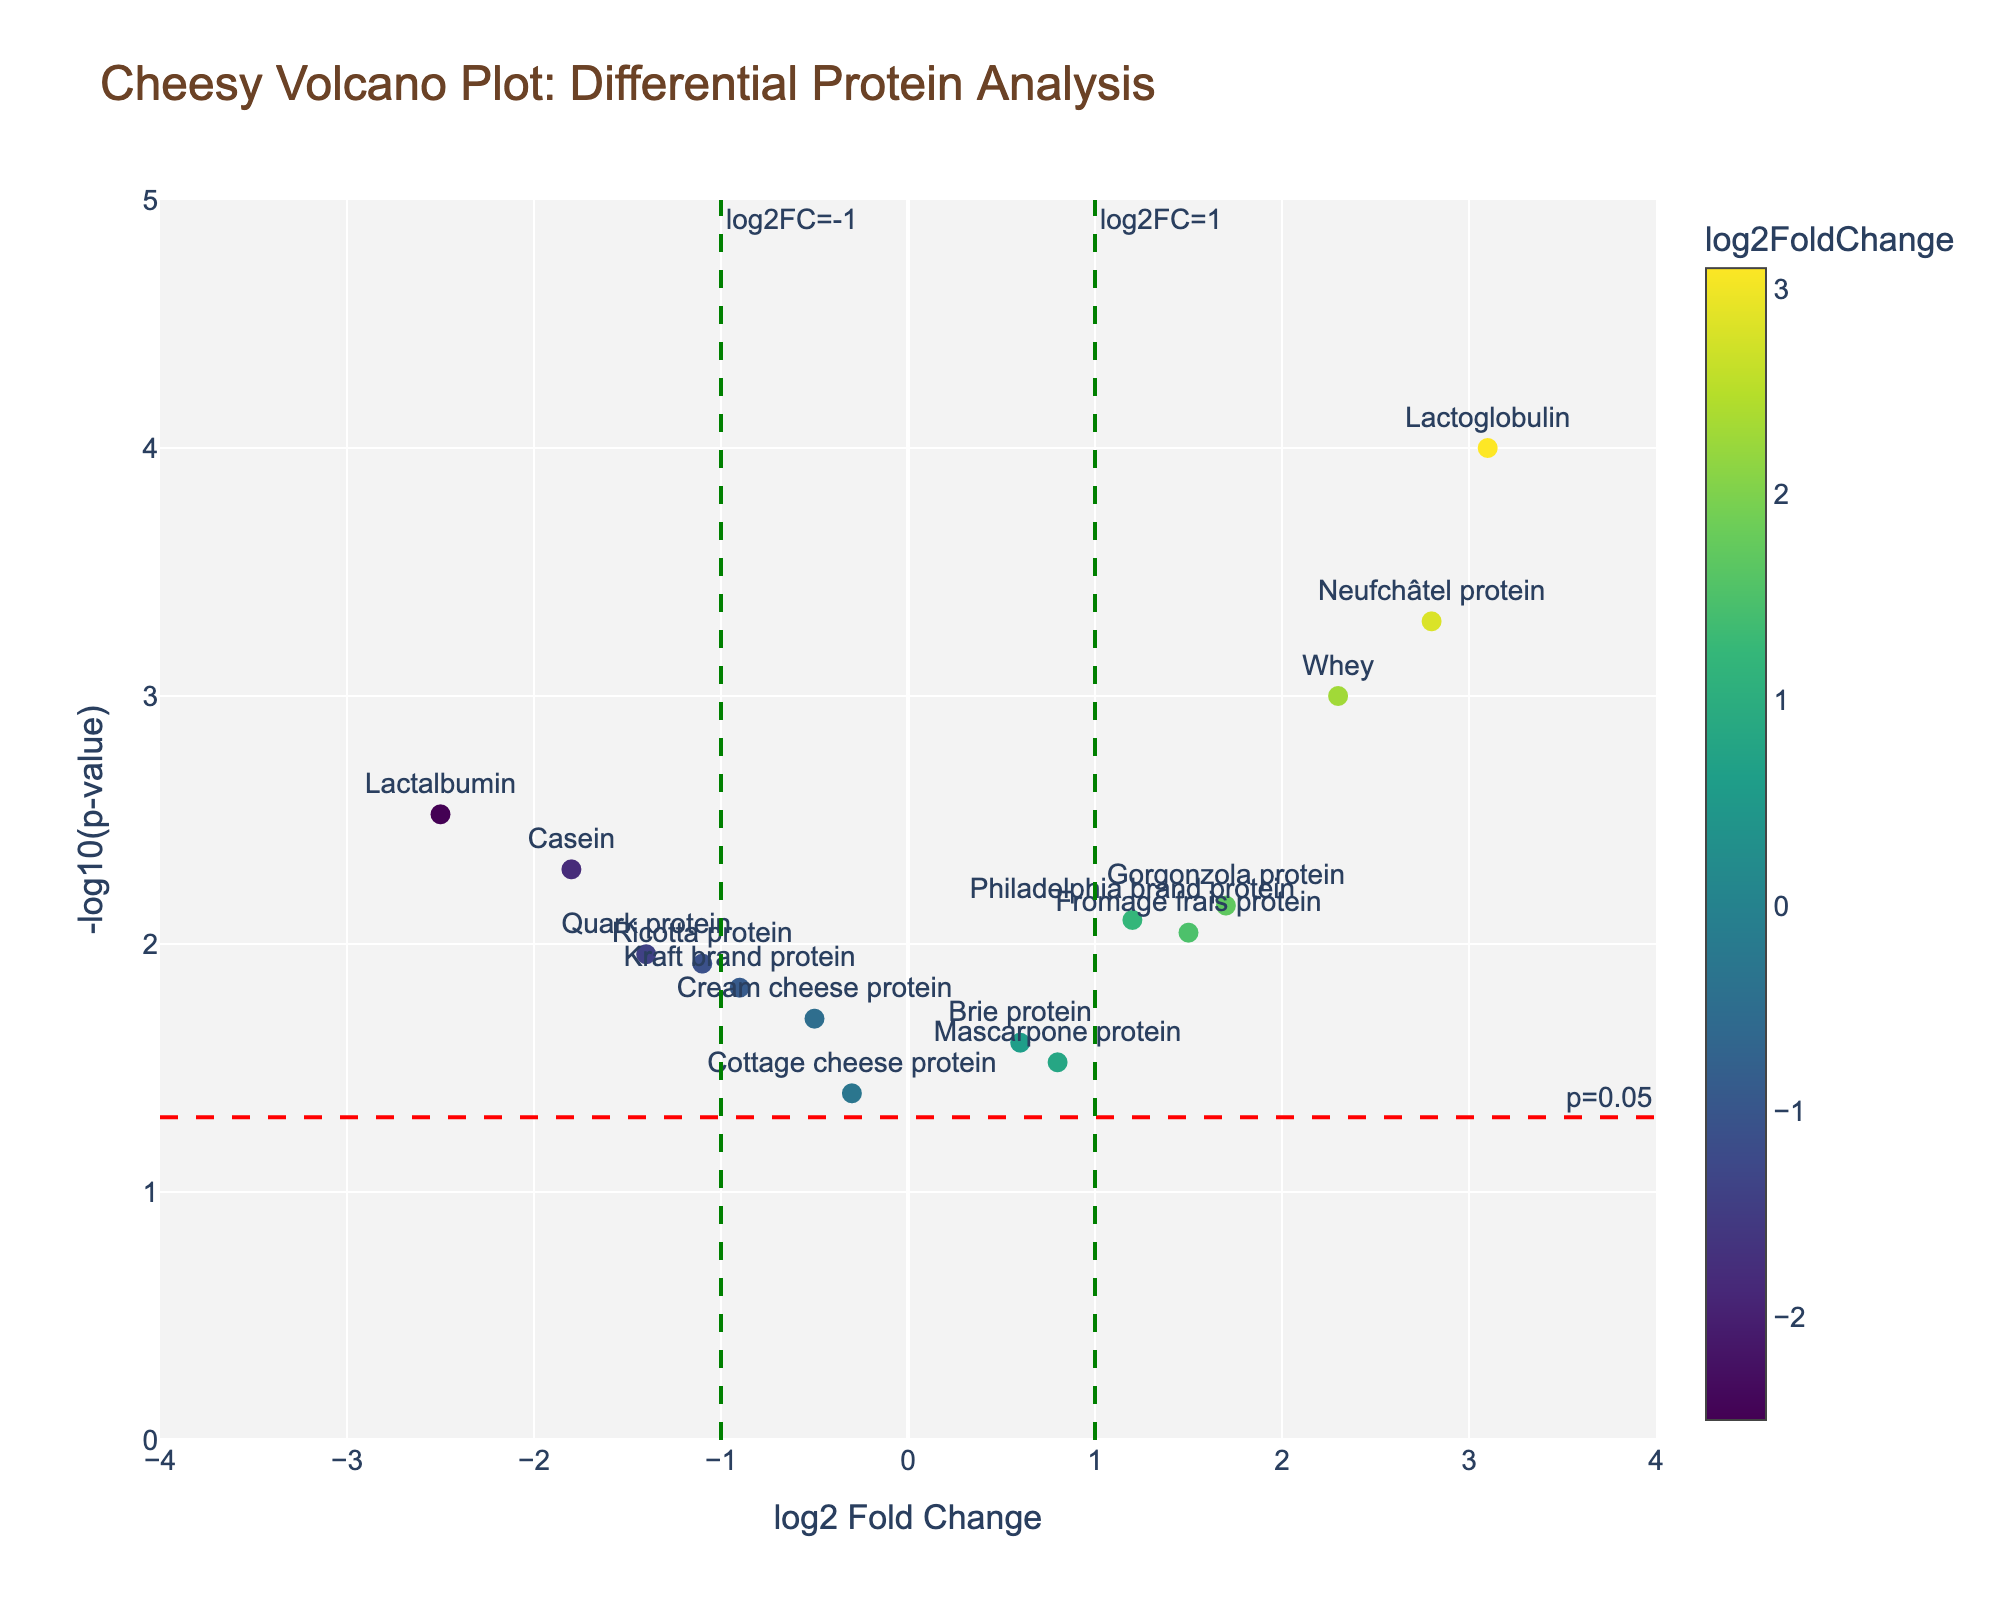What is the title of the plot? Look at the top of the plot where the title is displayed.
Answer: Cheesy Volcano Plot: Differential Protein Analysis How many data points have a log2 Fold Change greater than 1? Count the data points that are positioned to the right of the vertical green line at log2FC=1.
Answer: 4 Which protein has the highest -log10(p-value)? Search for the data point with the highest y-axis value.
Answer: Lactoglobulin What is the log2 Fold Change for Neufchâtel protein? Find the Neufchâtel protein label on the plot and read its x-axis value (log2 Fold Change).
Answer: 2.8 How many proteins are significantly different with a p-value of less than 0.05? Count the number of data points above the red horizontal line, which marks -log10(0.05).
Answer: 9 Which protein has a log2 Fold Change close to zero and an insignificant p-value? Look for a data point near the center of the plot along the x-axis with a y-axis value below the red horizontal line (-log10(0.05)).
Answer: Cottage cheese protein Between Philadelphia brand protein and Kraft brand protein, which has a larger absolute log2 Fold Change? Compare the absolute values of their log2 Fold Change by locating their positions on the x-axis and measuring the distance from zero.
Answer: Kraft brand protein What p-value corresponds to the protein with the lowest log2 Fold Change? Find the protein with the lowest log2 Fold Change (most negative x-axis) and read its p-value from the hover text or hover over it.
Answer: 0.003 (Lactalbumin) How many proteins have a negative log2 Fold Change? Count the data points positioned to the left of the origin (zero) on the x-axis.
Answer: 6 